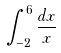<formula> <loc_0><loc_0><loc_500><loc_500>\int _ { - 2 } ^ { 6 } \frac { d x } { x }</formula> 